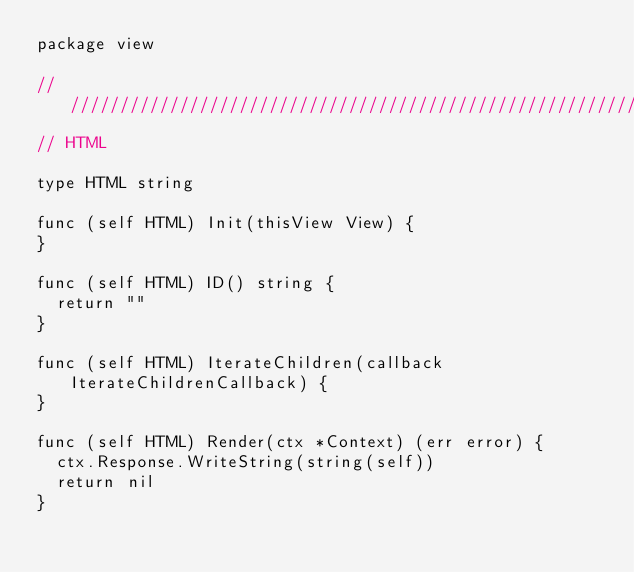<code> <loc_0><loc_0><loc_500><loc_500><_Go_>package view

///////////////////////////////////////////////////////////////////////////////
// HTML

type HTML string

func (self HTML) Init(thisView View) {
}

func (self HTML) ID() string {
	return ""
}

func (self HTML) IterateChildren(callback IterateChildrenCallback) {
}

func (self HTML) Render(ctx *Context) (err error) {
	ctx.Response.WriteString(string(self))
	return nil
}
</code> 